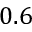<formula> <loc_0><loc_0><loc_500><loc_500>0 . 6</formula> 